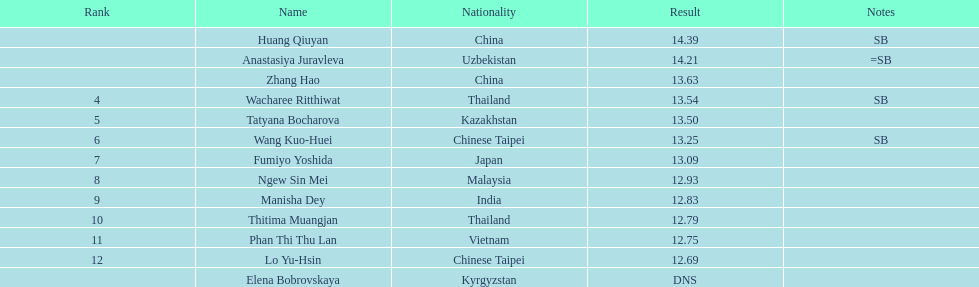What was the number of athletes representing china? 2. Write the full table. {'header': ['Rank', 'Name', 'Nationality', 'Result', 'Notes'], 'rows': [['', 'Huang Qiuyan', 'China', '14.39', 'SB'], ['', 'Anastasiya Juravleva', 'Uzbekistan', '14.21', '=SB'], ['', 'Zhang Hao', 'China', '13.63', ''], ['4', 'Wacharee Ritthiwat', 'Thailand', '13.54', 'SB'], ['5', 'Tatyana Bocharova', 'Kazakhstan', '13.50', ''], ['6', 'Wang Kuo-Huei', 'Chinese Taipei', '13.25', 'SB'], ['7', 'Fumiyo Yoshida', 'Japan', '13.09', ''], ['8', 'Ngew Sin Mei', 'Malaysia', '12.93', ''], ['9', 'Manisha Dey', 'India', '12.83', ''], ['10', 'Thitima Muangjan', 'Thailand', '12.79', ''], ['11', 'Phan Thi Thu Lan', 'Vietnam', '12.75', ''], ['12', 'Lo Yu-Hsin', 'Chinese Taipei', '12.69', ''], ['', 'Elena Bobrovskaya', 'Kyrgyzstan', 'DNS', '']]} 